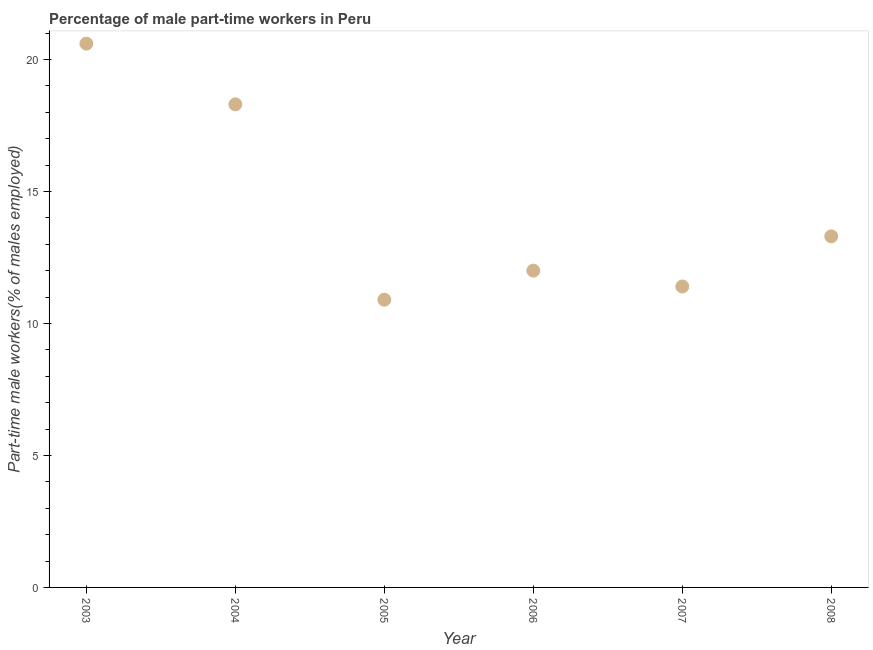What is the percentage of part-time male workers in 2005?
Provide a short and direct response. 10.9. Across all years, what is the maximum percentage of part-time male workers?
Provide a short and direct response. 20.6. Across all years, what is the minimum percentage of part-time male workers?
Keep it short and to the point. 10.9. In which year was the percentage of part-time male workers maximum?
Offer a terse response. 2003. In which year was the percentage of part-time male workers minimum?
Your answer should be very brief. 2005. What is the sum of the percentage of part-time male workers?
Offer a terse response. 86.5. What is the difference between the percentage of part-time male workers in 2006 and 2007?
Your answer should be very brief. 0.6. What is the average percentage of part-time male workers per year?
Ensure brevity in your answer.  14.42. What is the median percentage of part-time male workers?
Ensure brevity in your answer.  12.65. Do a majority of the years between 2007 and 2004 (inclusive) have percentage of part-time male workers greater than 19 %?
Your answer should be compact. Yes. What is the ratio of the percentage of part-time male workers in 2003 to that in 2007?
Offer a very short reply. 1.81. Is the percentage of part-time male workers in 2004 less than that in 2008?
Your response must be concise. No. What is the difference between the highest and the second highest percentage of part-time male workers?
Provide a short and direct response. 2.3. What is the difference between the highest and the lowest percentage of part-time male workers?
Give a very brief answer. 9.7. How many dotlines are there?
Provide a succinct answer. 1. Are the values on the major ticks of Y-axis written in scientific E-notation?
Ensure brevity in your answer.  No. Does the graph contain grids?
Ensure brevity in your answer.  No. What is the title of the graph?
Your answer should be very brief. Percentage of male part-time workers in Peru. What is the label or title of the Y-axis?
Give a very brief answer. Part-time male workers(% of males employed). What is the Part-time male workers(% of males employed) in 2003?
Make the answer very short. 20.6. What is the Part-time male workers(% of males employed) in 2004?
Offer a terse response. 18.3. What is the Part-time male workers(% of males employed) in 2005?
Provide a succinct answer. 10.9. What is the Part-time male workers(% of males employed) in 2007?
Your answer should be compact. 11.4. What is the Part-time male workers(% of males employed) in 2008?
Ensure brevity in your answer.  13.3. What is the difference between the Part-time male workers(% of males employed) in 2003 and 2004?
Provide a short and direct response. 2.3. What is the difference between the Part-time male workers(% of males employed) in 2003 and 2007?
Your response must be concise. 9.2. What is the difference between the Part-time male workers(% of males employed) in 2004 and 2006?
Your answer should be very brief. 6.3. What is the difference between the Part-time male workers(% of males employed) in 2004 and 2008?
Offer a terse response. 5. What is the difference between the Part-time male workers(% of males employed) in 2005 and 2007?
Make the answer very short. -0.5. What is the difference between the Part-time male workers(% of males employed) in 2005 and 2008?
Your answer should be compact. -2.4. What is the difference between the Part-time male workers(% of males employed) in 2006 and 2007?
Your answer should be compact. 0.6. What is the difference between the Part-time male workers(% of males employed) in 2006 and 2008?
Offer a terse response. -1.3. What is the difference between the Part-time male workers(% of males employed) in 2007 and 2008?
Offer a terse response. -1.9. What is the ratio of the Part-time male workers(% of males employed) in 2003 to that in 2004?
Keep it short and to the point. 1.13. What is the ratio of the Part-time male workers(% of males employed) in 2003 to that in 2005?
Make the answer very short. 1.89. What is the ratio of the Part-time male workers(% of males employed) in 2003 to that in 2006?
Offer a terse response. 1.72. What is the ratio of the Part-time male workers(% of males employed) in 2003 to that in 2007?
Provide a succinct answer. 1.81. What is the ratio of the Part-time male workers(% of males employed) in 2003 to that in 2008?
Provide a succinct answer. 1.55. What is the ratio of the Part-time male workers(% of males employed) in 2004 to that in 2005?
Give a very brief answer. 1.68. What is the ratio of the Part-time male workers(% of males employed) in 2004 to that in 2006?
Make the answer very short. 1.52. What is the ratio of the Part-time male workers(% of males employed) in 2004 to that in 2007?
Your answer should be very brief. 1.6. What is the ratio of the Part-time male workers(% of males employed) in 2004 to that in 2008?
Provide a succinct answer. 1.38. What is the ratio of the Part-time male workers(% of males employed) in 2005 to that in 2006?
Offer a terse response. 0.91. What is the ratio of the Part-time male workers(% of males employed) in 2005 to that in 2007?
Your answer should be compact. 0.96. What is the ratio of the Part-time male workers(% of males employed) in 2005 to that in 2008?
Keep it short and to the point. 0.82. What is the ratio of the Part-time male workers(% of males employed) in 2006 to that in 2007?
Make the answer very short. 1.05. What is the ratio of the Part-time male workers(% of males employed) in 2006 to that in 2008?
Keep it short and to the point. 0.9. What is the ratio of the Part-time male workers(% of males employed) in 2007 to that in 2008?
Offer a very short reply. 0.86. 